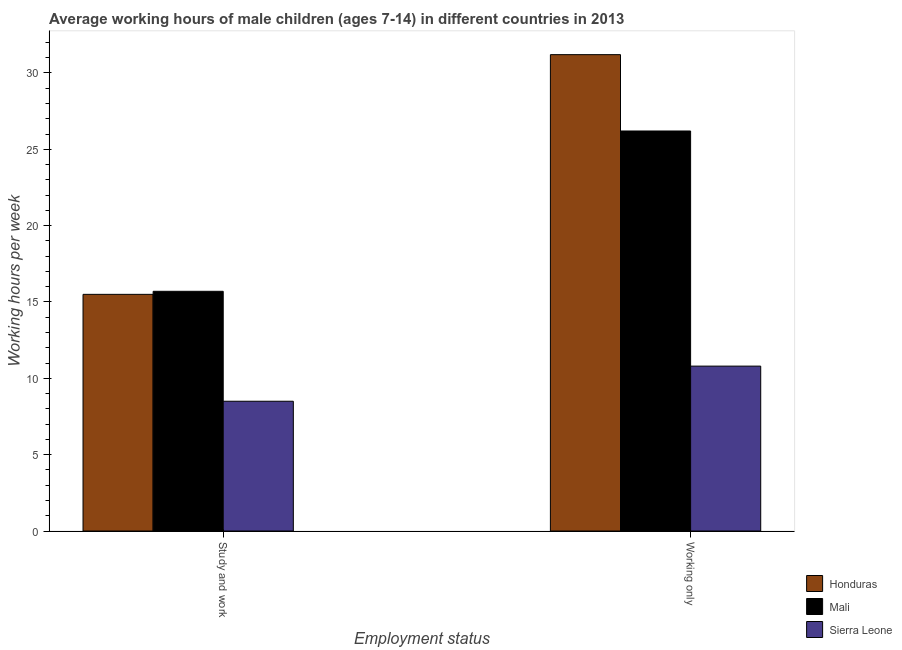How many different coloured bars are there?
Offer a terse response. 3. Are the number of bars per tick equal to the number of legend labels?
Provide a succinct answer. Yes. Are the number of bars on each tick of the X-axis equal?
Provide a short and direct response. Yes. How many bars are there on the 2nd tick from the left?
Offer a terse response. 3. How many bars are there on the 2nd tick from the right?
Your response must be concise. 3. What is the label of the 2nd group of bars from the left?
Your answer should be very brief. Working only. Across all countries, what is the maximum average working hour of children involved in study and work?
Offer a very short reply. 15.7. Across all countries, what is the minimum average working hour of children involved in only work?
Provide a short and direct response. 10.8. In which country was the average working hour of children involved in only work maximum?
Make the answer very short. Honduras. In which country was the average working hour of children involved in only work minimum?
Make the answer very short. Sierra Leone. What is the total average working hour of children involved in study and work in the graph?
Provide a succinct answer. 39.7. What is the difference between the average working hour of children involved in study and work in Sierra Leone and that in Mali?
Give a very brief answer. -7.2. What is the difference between the average working hour of children involved in study and work in Sierra Leone and the average working hour of children involved in only work in Mali?
Provide a short and direct response. -17.7. What is the average average working hour of children involved in study and work per country?
Give a very brief answer. 13.23. What is the difference between the average working hour of children involved in study and work and average working hour of children involved in only work in Sierra Leone?
Give a very brief answer. -2.3. What is the ratio of the average working hour of children involved in study and work in Honduras to that in Mali?
Your answer should be compact. 0.99. In how many countries, is the average working hour of children involved in only work greater than the average average working hour of children involved in only work taken over all countries?
Offer a terse response. 2. What does the 2nd bar from the left in Study and work represents?
Offer a very short reply. Mali. What does the 2nd bar from the right in Study and work represents?
Your response must be concise. Mali. How many bars are there?
Your answer should be compact. 6. Are all the bars in the graph horizontal?
Offer a very short reply. No. How many countries are there in the graph?
Offer a terse response. 3. What is the difference between two consecutive major ticks on the Y-axis?
Keep it short and to the point. 5. Are the values on the major ticks of Y-axis written in scientific E-notation?
Provide a short and direct response. No. Does the graph contain grids?
Your answer should be very brief. No. How are the legend labels stacked?
Offer a terse response. Vertical. What is the title of the graph?
Your response must be concise. Average working hours of male children (ages 7-14) in different countries in 2013. What is the label or title of the X-axis?
Provide a succinct answer. Employment status. What is the label or title of the Y-axis?
Offer a terse response. Working hours per week. What is the Working hours per week in Honduras in Study and work?
Ensure brevity in your answer.  15.5. What is the Working hours per week in Sierra Leone in Study and work?
Make the answer very short. 8.5. What is the Working hours per week of Honduras in Working only?
Provide a short and direct response. 31.2. What is the Working hours per week in Mali in Working only?
Provide a succinct answer. 26.2. Across all Employment status, what is the maximum Working hours per week of Honduras?
Provide a succinct answer. 31.2. Across all Employment status, what is the maximum Working hours per week of Mali?
Your answer should be compact. 26.2. Across all Employment status, what is the minimum Working hours per week in Mali?
Ensure brevity in your answer.  15.7. Across all Employment status, what is the minimum Working hours per week of Sierra Leone?
Your response must be concise. 8.5. What is the total Working hours per week in Honduras in the graph?
Offer a terse response. 46.7. What is the total Working hours per week in Mali in the graph?
Offer a terse response. 41.9. What is the total Working hours per week of Sierra Leone in the graph?
Your answer should be compact. 19.3. What is the difference between the Working hours per week in Honduras in Study and work and that in Working only?
Provide a short and direct response. -15.7. What is the difference between the Working hours per week in Mali in Study and work and that in Working only?
Provide a succinct answer. -10.5. What is the difference between the Working hours per week of Sierra Leone in Study and work and that in Working only?
Keep it short and to the point. -2.3. What is the difference between the Working hours per week in Honduras in Study and work and the Working hours per week in Mali in Working only?
Your response must be concise. -10.7. What is the difference between the Working hours per week in Mali in Study and work and the Working hours per week in Sierra Leone in Working only?
Make the answer very short. 4.9. What is the average Working hours per week in Honduras per Employment status?
Provide a succinct answer. 23.35. What is the average Working hours per week in Mali per Employment status?
Provide a short and direct response. 20.95. What is the average Working hours per week of Sierra Leone per Employment status?
Keep it short and to the point. 9.65. What is the difference between the Working hours per week in Honduras and Working hours per week in Mali in Study and work?
Offer a very short reply. -0.2. What is the difference between the Working hours per week of Honduras and Working hours per week of Mali in Working only?
Provide a succinct answer. 5. What is the difference between the Working hours per week of Honduras and Working hours per week of Sierra Leone in Working only?
Provide a short and direct response. 20.4. What is the difference between the Working hours per week of Mali and Working hours per week of Sierra Leone in Working only?
Offer a terse response. 15.4. What is the ratio of the Working hours per week in Honduras in Study and work to that in Working only?
Provide a succinct answer. 0.5. What is the ratio of the Working hours per week in Mali in Study and work to that in Working only?
Your answer should be very brief. 0.6. What is the ratio of the Working hours per week of Sierra Leone in Study and work to that in Working only?
Ensure brevity in your answer.  0.79. What is the difference between the highest and the second highest Working hours per week of Sierra Leone?
Your response must be concise. 2.3. What is the difference between the highest and the lowest Working hours per week in Honduras?
Your answer should be very brief. 15.7. 